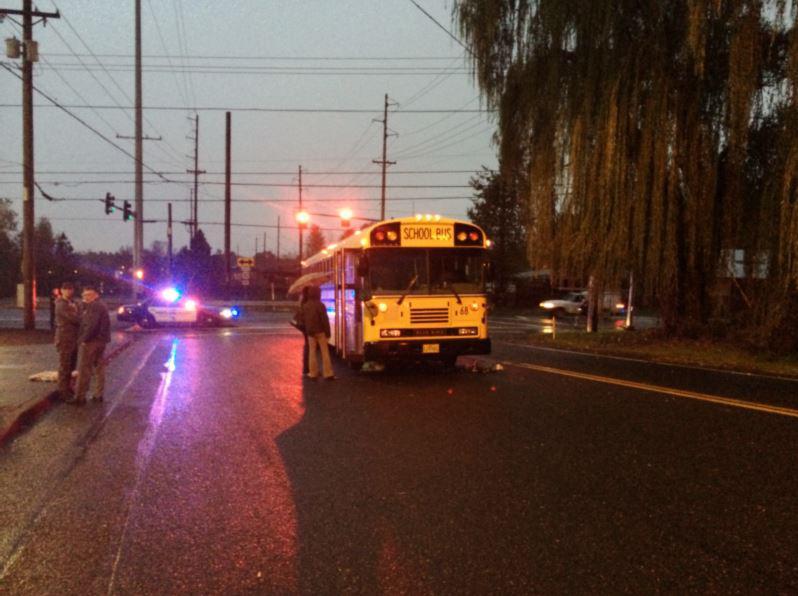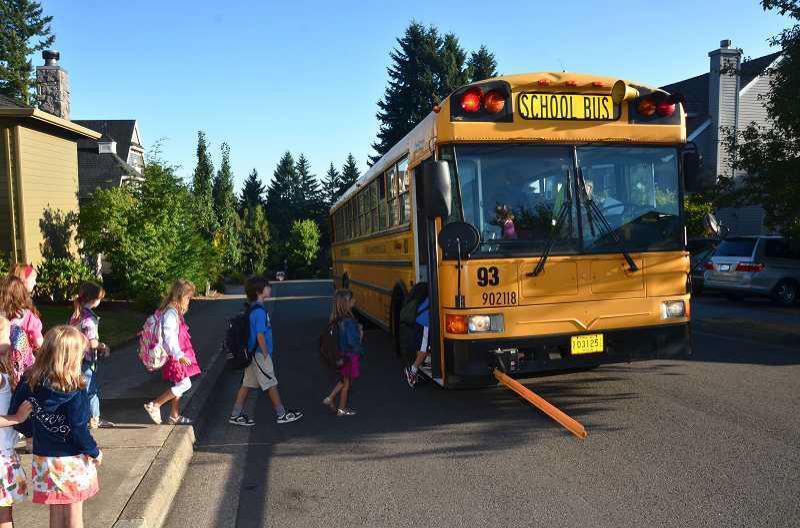The first image is the image on the left, the second image is the image on the right. Examine the images to the left and right. Is the description "The buses on the left and right both face forward and angle slightly rightward, and people stand in front of the open door of at least one bus." accurate? Answer yes or no. Yes. The first image is the image on the left, the second image is the image on the right. For the images shown, is this caption "The school bus is in the stopped position." true? Answer yes or no. Yes. 